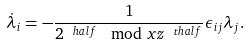Convert formula to latex. <formula><loc_0><loc_0><loc_500><loc_500>\dot { \lambda } _ { i } = - \frac { 1 } { 2 ^ { \ h a l f } \mod x z ^ { \ t h a l f } } \epsilon _ { i j } \lambda _ { j } .</formula> 